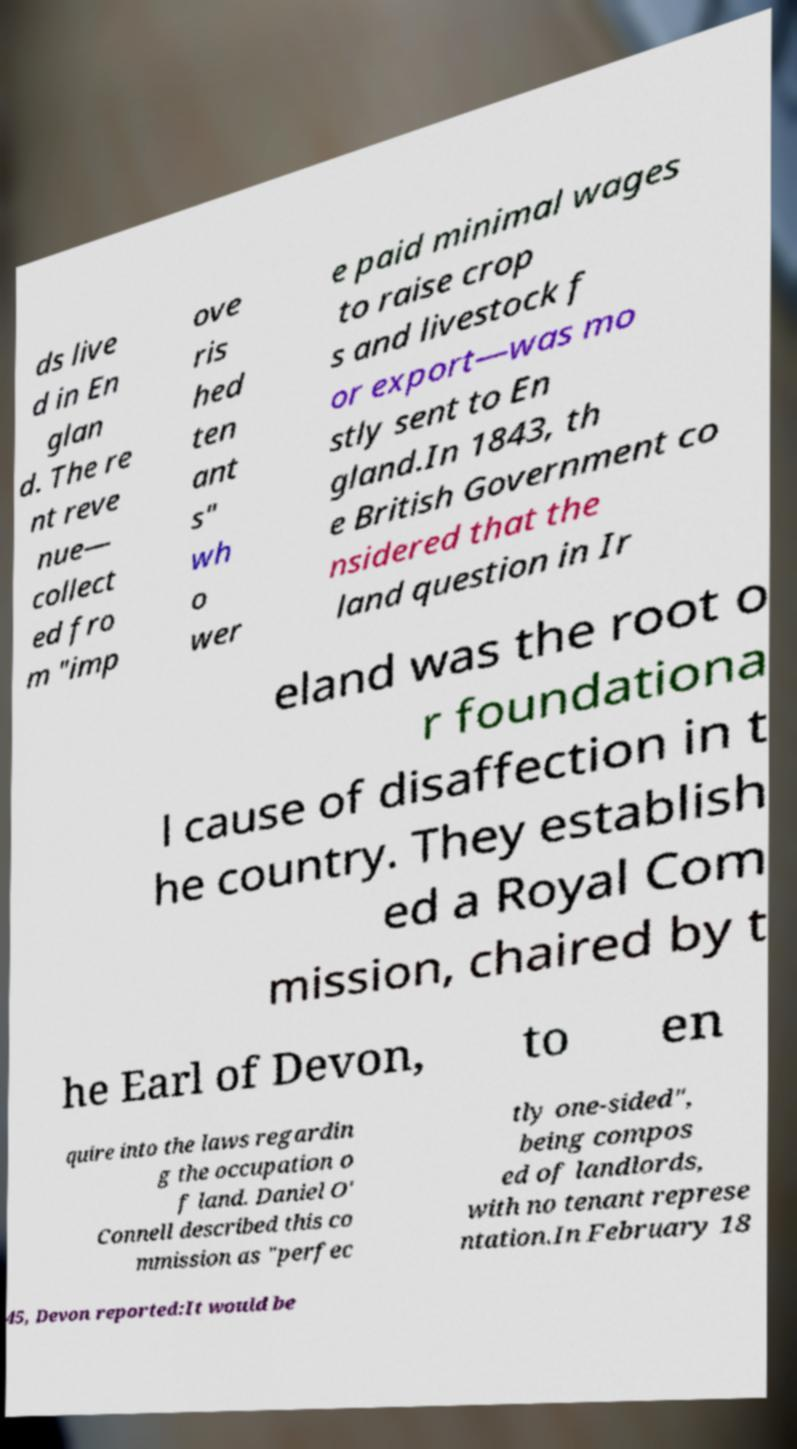Can you accurately transcribe the text from the provided image for me? ds live d in En glan d. The re nt reve nue— collect ed fro m "imp ove ris hed ten ant s" wh o wer e paid minimal wages to raise crop s and livestock f or export—was mo stly sent to En gland.In 1843, th e British Government co nsidered that the land question in Ir eland was the root o r foundationa l cause of disaffection in t he country. They establish ed a Royal Com mission, chaired by t he Earl of Devon, to en quire into the laws regardin g the occupation o f land. Daniel O' Connell described this co mmission as "perfec tly one-sided", being compos ed of landlords, with no tenant represe ntation.In February 18 45, Devon reported:It would be 